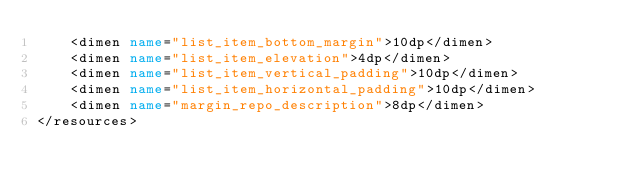<code> <loc_0><loc_0><loc_500><loc_500><_XML_>    <dimen name="list_item_bottom_margin">10dp</dimen>
    <dimen name="list_item_elevation">4dp</dimen>
    <dimen name="list_item_vertical_padding">10dp</dimen>
    <dimen name="list_item_horizontal_padding">10dp</dimen>
    <dimen name="margin_repo_description">8dp</dimen>
</resources></code> 